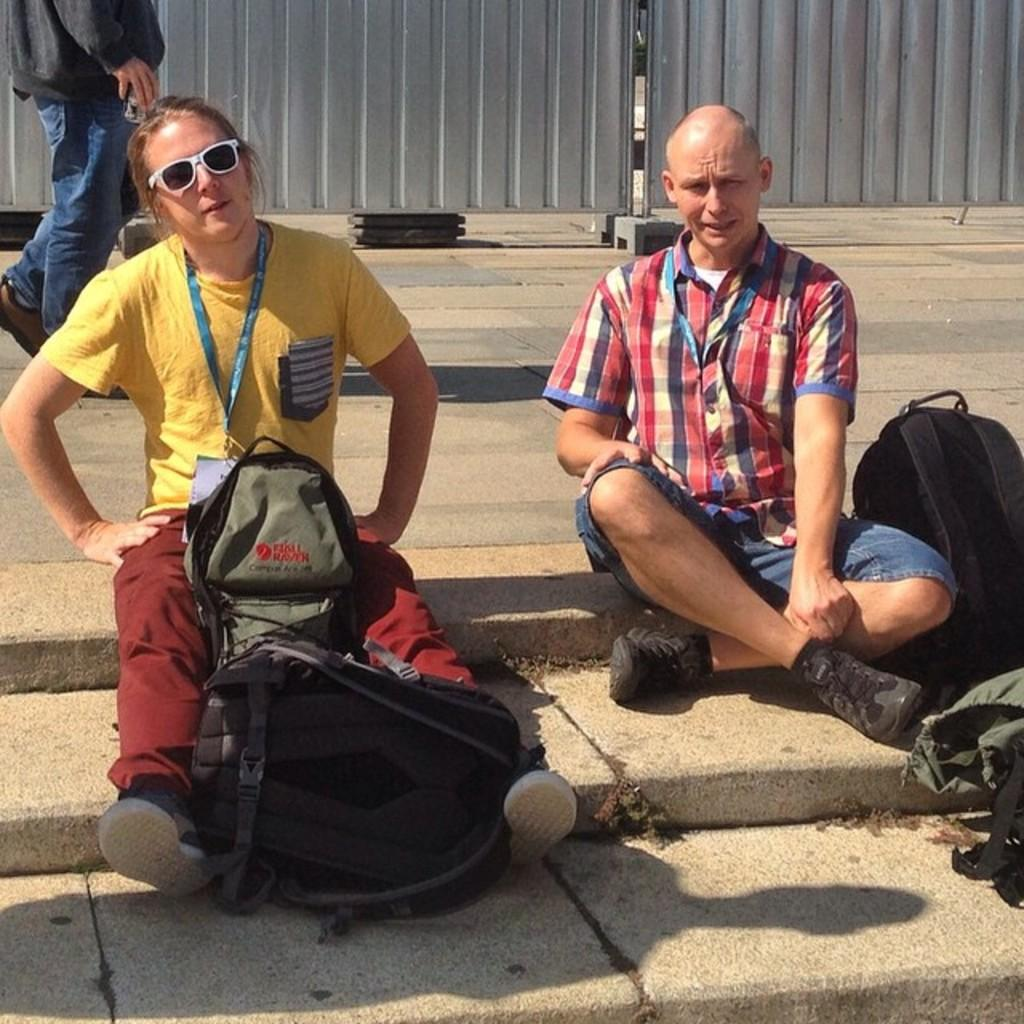How many people are sitting on the floor in the image? There are two persons sitting on the floor in the image. What else can be seen in the image besides the people sitting on the floor? There are bags in the image. What is one person wearing that is not typical for everyday wear? One person is wearing goggles. What is happening in the background of the image? There is a person walking on the road in the background of the image. How many family members are present in the image? The provided facts do not mention any family members, so we cannot determine the number of family members present in the image. What type of drawer is visible in the image? There is no drawer present in the image. 